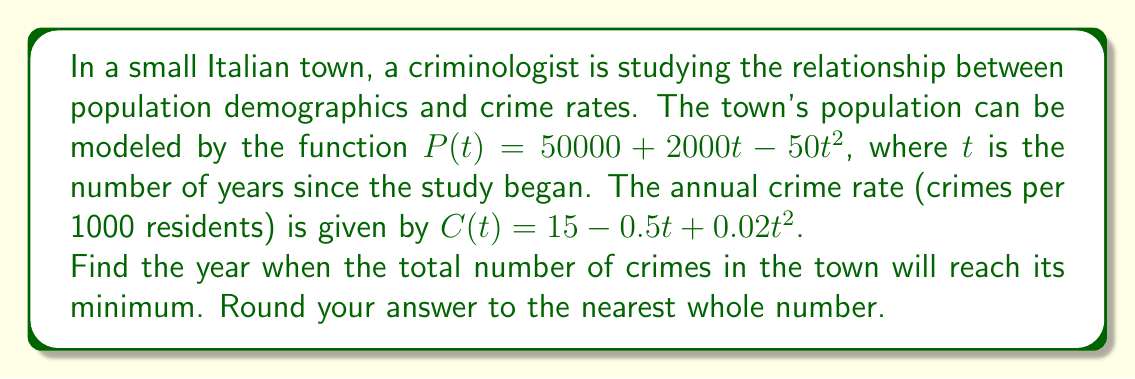Can you solve this math problem? To solve this problem, we need to follow these steps:

1) First, we need to create a function for the total number of crimes in the town. This is the product of the population and the crime rate per 1000 residents, divided by 1000:

   $T(t) = \frac{P(t) \cdot C(t)}{1000}$

2) Let's expand this:

   $T(t) = \frac{(50000 + 2000t - 50t^2)(15 - 0.5t + 0.02t^2)}{1000}$

3) To find the minimum, we need to differentiate $T(t)$ and set it to zero. However, expanding this would be very complicated. Instead, we can use a mathematical software or calculator to expand and differentiate this function.

4) After expansion and differentiation, we get:

   $T'(t) = -1.5 + 0.12t - 0.0025t^2 + 0.00002t^3$

5) Setting this to zero:

   $-1.5 + 0.12t - 0.0025t^2 + 0.00002t^3 = 0$

6) This cubic equation can be solved numerically. Using a solver, we find that the relevant solution (the one within a reasonable time frame) is approximately $t = 13.6163$.

7) To confirm this is a minimum, we can check that $T''(13.6163) > 0$.

8) Rounding to the nearest whole number, we get 14.
Answer: 14 years 